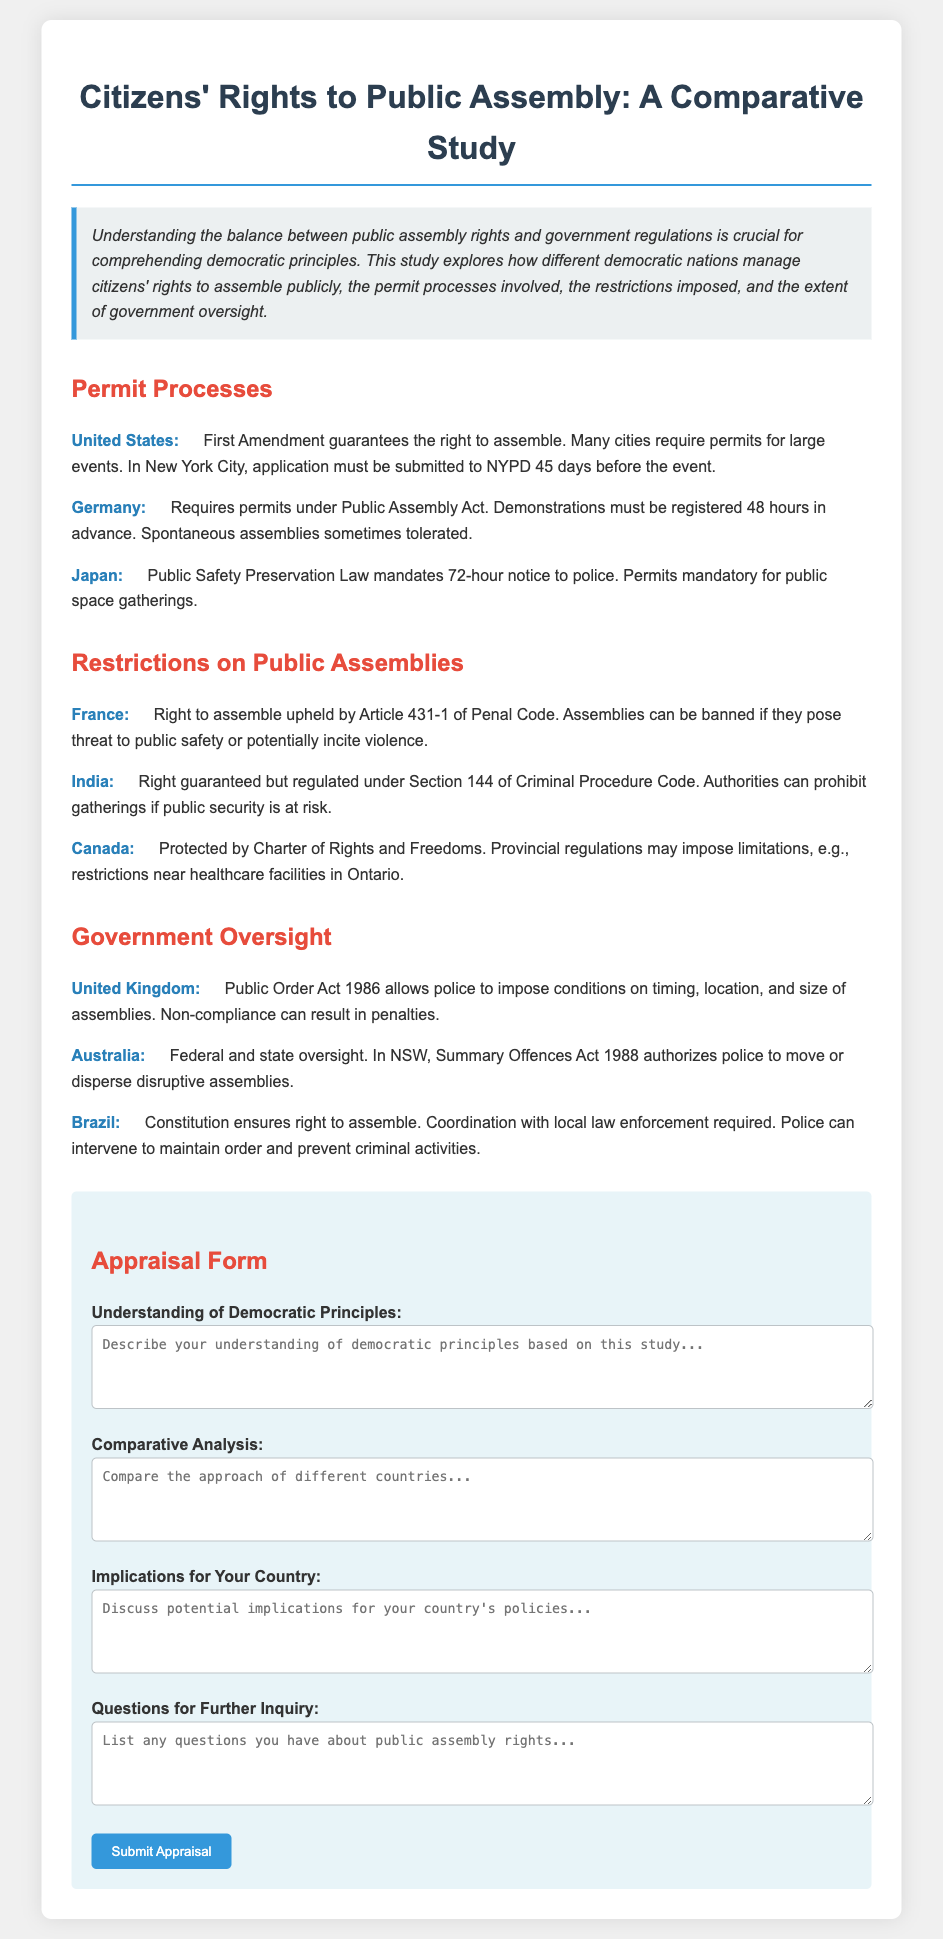what is the required notice for public assemblies in Japan? Japan mandates a notice of 72 hours to the police for public gatherings according to the Public Safety Preservation Law.
Answer: 72 hours which country requires the assembly to be registered 48 hours in advance? Germany requires demonstrations to be registered 48 hours before they occur under the Public Assembly Act.
Answer: Germany what document protects the right to assemble in Canada? The right to assemble in Canada is protected by the Charter of Rights and Freedoms.
Answer: Charter of Rights and Freedoms what can be a reason for banning assemblies in France? Assemblies in France can be banned if they pose a threat to public safety or potentially incite violence under Article 431-1 of the Penal Code.
Answer: Threat to public safety which act allows the police in the United Kingdom to impose conditions on assemblies? The Public Order Act 1986 allows police to impose conditions on the timing, location, and size of assemblies in the United Kingdom.
Answer: Public Order Act 1986 how many days in advance must applications be submitted in New York City for large events? In New York City, applications for large events must be submitted 45 days in advance.
Answer: 45 days what is the purpose of the Summary Offences Act 1988 in New South Wales, Australia? The Summary Offences Act 1988 in New South Wales authorizes police to move or disperse disruptive assemblies.
Answer: Disperse disruptive assemblies what should you include in the appraisal form regarding the implications for your country? The appraisal form prompts to discuss potential implications based on the study for your country's policies.
Answer: Potential implications for your country's policies which country requires coordination with local law enforcement for public assemblies? Brazil's constitution ensures the right to assemble with required coordination with local law enforcement.
Answer: Brazil 